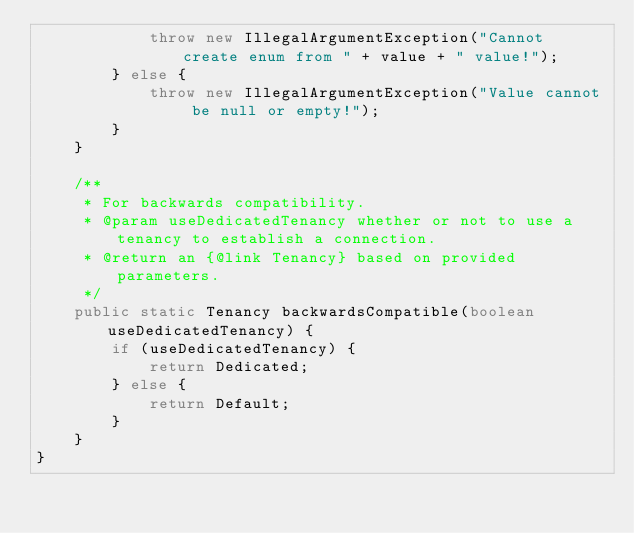<code> <loc_0><loc_0><loc_500><loc_500><_Java_>            throw new IllegalArgumentException("Cannot create enum from " + value + " value!");
        } else {
            throw new IllegalArgumentException("Value cannot be null or empty!");
        }
    }

    /**
     * For backwards compatibility.
     * @param useDedicatedTenancy whether or not to use a tenancy to establish a connection.
     * @return an {@link Tenancy} based on provided parameters.
     */
    public static Tenancy backwardsCompatible(boolean useDedicatedTenancy) {
        if (useDedicatedTenancy) {
            return Dedicated;
        } else {
            return Default;
        }
    }
}

</code> 